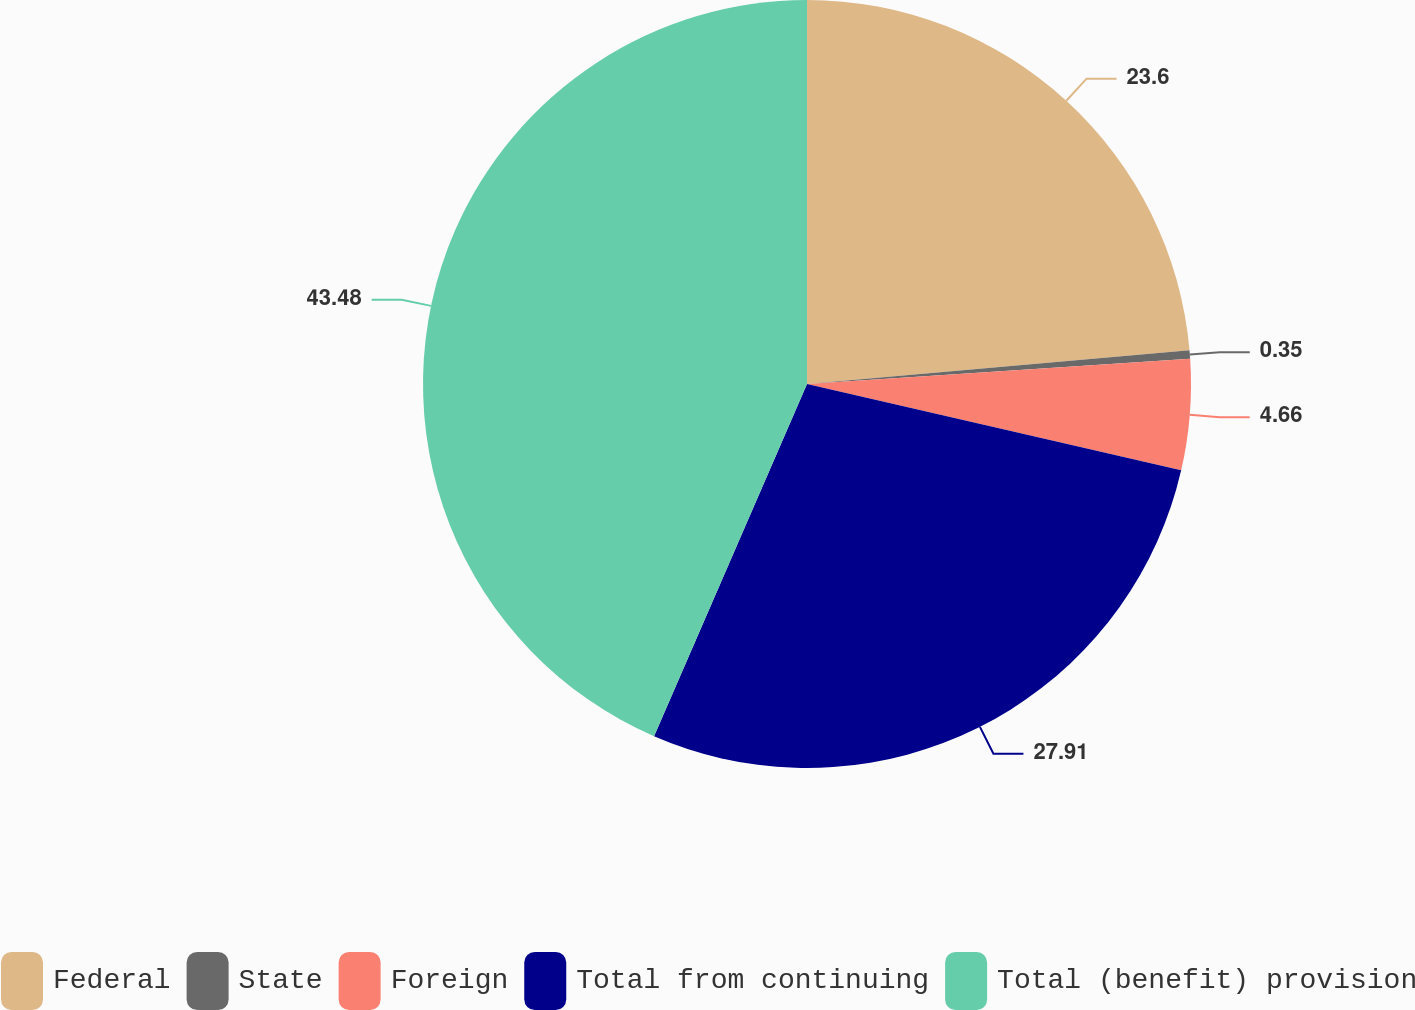Convert chart to OTSL. <chart><loc_0><loc_0><loc_500><loc_500><pie_chart><fcel>Federal<fcel>State<fcel>Foreign<fcel>Total from continuing<fcel>Total (benefit) provision<nl><fcel>23.6%<fcel>0.35%<fcel>4.66%<fcel>27.91%<fcel>43.48%<nl></chart> 